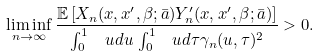<formula> <loc_0><loc_0><loc_500><loc_500>\liminf _ { n \to \infty } \frac { \mathbb { E } \left [ X _ { n } ( x , x ^ { \prime } , \beta ; \bar { a } ) Y ^ { \prime } _ { n } ( x , x ^ { \prime } , \beta ; \bar { a } ) \right ] } { \int _ { 0 } ^ { 1 } \, \ u d u \, \int _ { 0 } ^ { 1 } \, \ u d \tau \gamma _ { n } ( u , \tau ) ^ { 2 } } > 0 .</formula> 